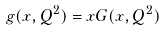<formula> <loc_0><loc_0><loc_500><loc_500>g ( x , Q ^ { 2 } ) = x G ( x , Q ^ { 2 } )</formula> 